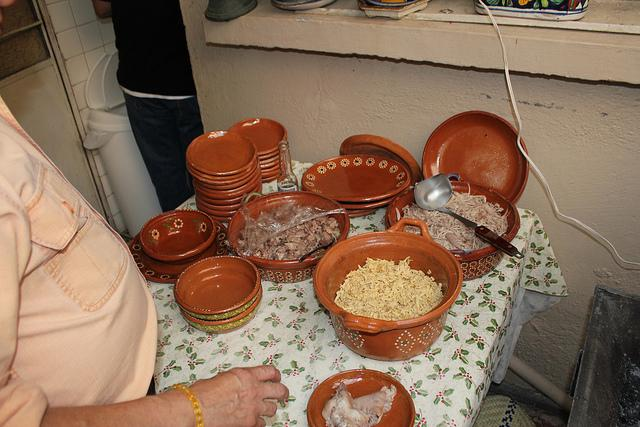Where is this food located?

Choices:
A) gas station
B) outside
C) home kitchen
D) restaurant home kitchen 